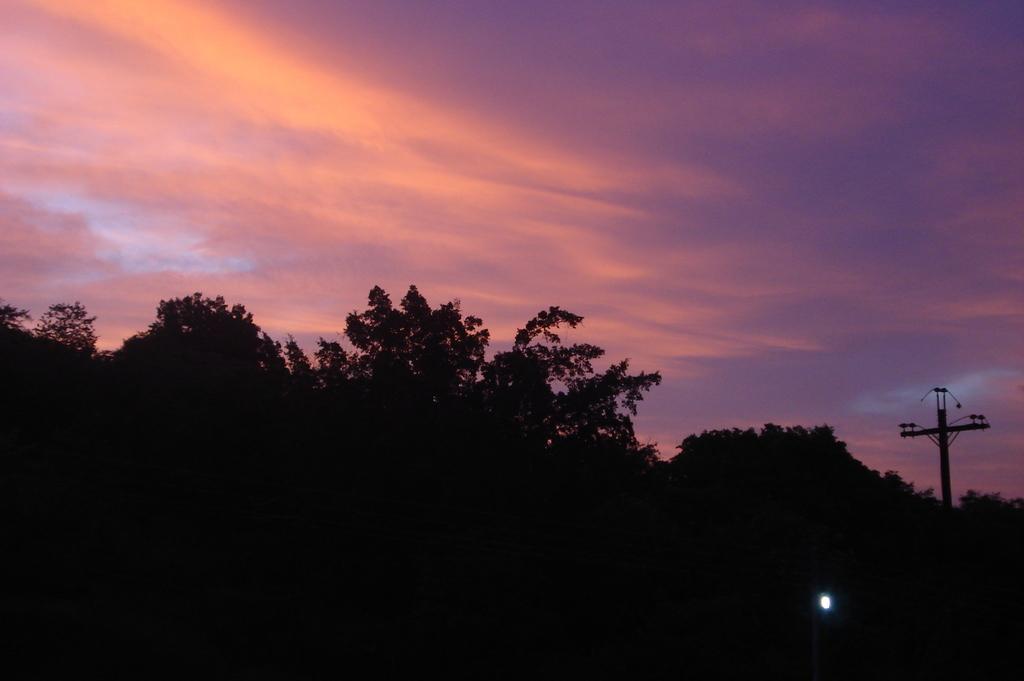Can you describe this image briefly? In this image I can see at the bottom there are trees. On the right side there is the light, at the top it is the sky. 